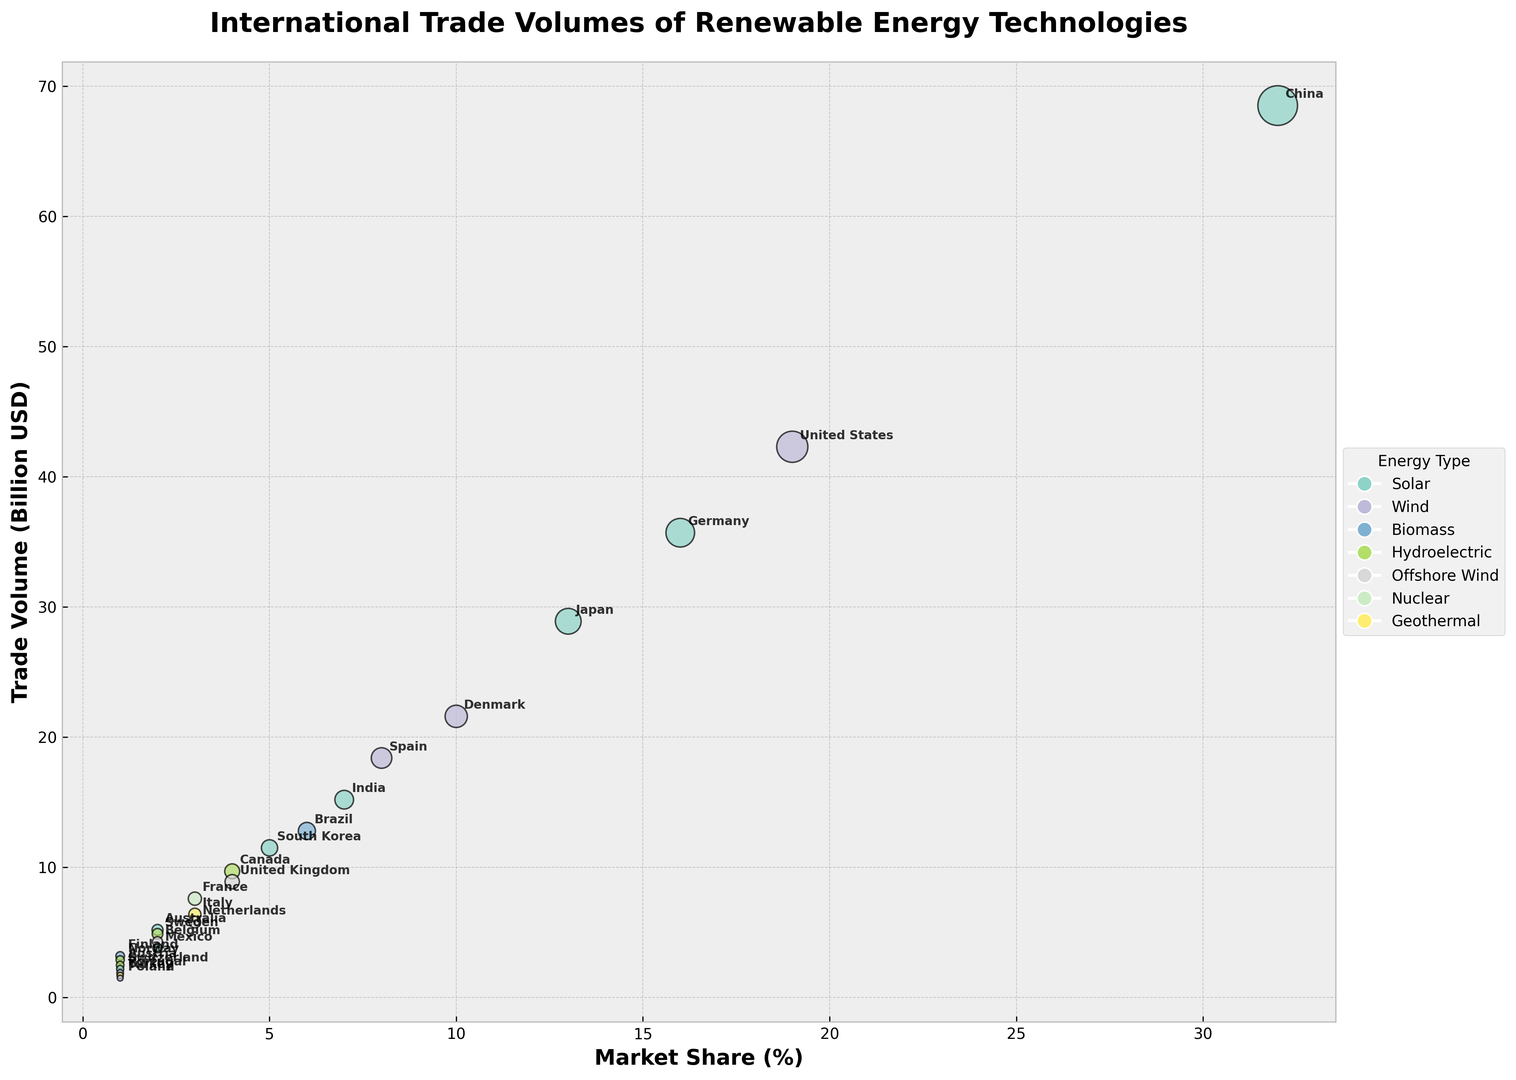Which country contributes the most to the Solar energy trade volume? By looking at the bubble chart, the size of the bubble for China in the Solar energy type is the largest. This indicates China contributes the most to the Solar energy trade volume.
Answer: China What is the combined trade volume of Solar energy for the top two countries? The top two countries in Solar energy trade volume are China (68.5 Billion USD) and Germany (35.7 Billion USD). Adding these amounts gives a total of 68.5 + 35.7 = 104.2 Billion USD.
Answer: 104.2 Billion USD Which has a higher market share in Wind energy trade, Denmark or Spain? Observe the legend, and then look at the market share axis to compare the bubble positions for Denmark and Spain under the Wind energy type. Denmark has a market share of 10%, while Spain has 8%, making Denmark's market share higher.
Answer: Denmark Which country dominates the Offshore Wind energy trade, and what is the trade volume? By looking at the color-coded bubbles for Offshore Wind and examining their sizes, the United Kingdom has the largest bubble, indicating it dominates with a trade volume of 8.9 Billion USD.
Answer: United Kingdom, 8.9 Billion USD What is the total market share of countries involved in Hydroelectric trade? Add the market shares of countries involved in Hydroelectric trade: Canada (4%), Sweden (2%), Austria (1%), and Norway (1%). The total is 4% + 2% + 1% + 1% = 8%.
Answer: 8% Compare the trade volumes of Biomass energy in Brazil and Finland. Which is larger and by how much? The trade volumes for Biomass energy are Brazil (12.8 Billion USD) and Finland (3.2 Billion USD). Subtracting Finland's volume from Brazil's volume gives 12.8 - 3.2 = 9.6 Billion USD, indicating Brazil's trade volume is larger by 9.6 Billion USD.
Answer: Brazil, 9.6 Billion USD What is the average market share of Solar energy trade among the listed countries? Identifying the market shares for Solar energy countries: China (32%), Germany (16%), Japan (13%), India (7%), South Korea (5%), Australia (2%), Mexico (2%), Switzerland (1%). Summing these, we get 32% + 16% + 13% + 7% + 5% + 2% + 2% + 1% = 78%. With 8 countries involved, the average is 78% / 8 = 9.75%.
Answer: 9.75% Which energy type has the most countries involved in trading according to the chart? Determine the number of unique countries trading each type: Solar (8), Wind (5), Hydroelectric (4), Offshore Wind (3), Biomass (2), Geothermal (2), Nuclear (1). Solar has the most countries involved with 8 countries.
Answer: Solar Between Hydroelectric and Geothermal energies, which has a greater total trade volume? Summing the trade volumes for Hydroelectric (Canada (9.7) + Sweden (4.9) + Austria (2.5) + Norway (2.9) = 20.0 Billion USD) and Geothermal (Italy (6.4) + Turkey (1.7) = 8.1 Billion USD), Hydroelectric has a greater total trade volume.
Answer: Hydroelectric How does the trade volume of Wind energy in the United States compare to that in Germany for Solar energy? By identifying the trade volumes for Wind energy in the United States (42.3 Billion USD) and Solar energy in Germany (35.7 Billion USD), we observe that the U.S. trade volume for Wind is larger than Germany's for Solar by 42.3 - 35.7 = 6.6 Billion USD.
Answer: 6.6 Billion USD 